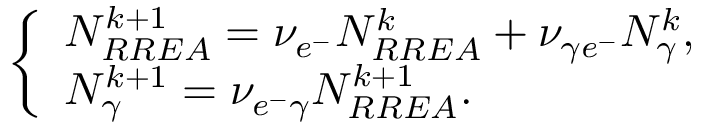Convert formula to latex. <formula><loc_0><loc_0><loc_500><loc_500>\left \{ \begin{array} { l l } { N _ { R R E A } ^ { k + 1 } = \nu _ { e ^ { - } } N _ { R R E A } ^ { k } + \nu _ { \gamma e ^ { - } } N _ { \gamma } ^ { k } , } \\ { N _ { \gamma } ^ { k + 1 } = \nu _ { e ^ { - } \gamma } N _ { R R E A } ^ { k + 1 } . } \end{array}</formula> 